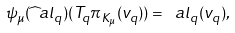Convert formula to latex. <formula><loc_0><loc_0><loc_500><loc_500>\psi _ { \mu } ( \widehat { \ } a l _ { q } ) ( T _ { q } \pi _ { K _ { \mu } } ( v _ { q } ) ) = \ a l _ { q } ( v _ { q } ) ,</formula> 